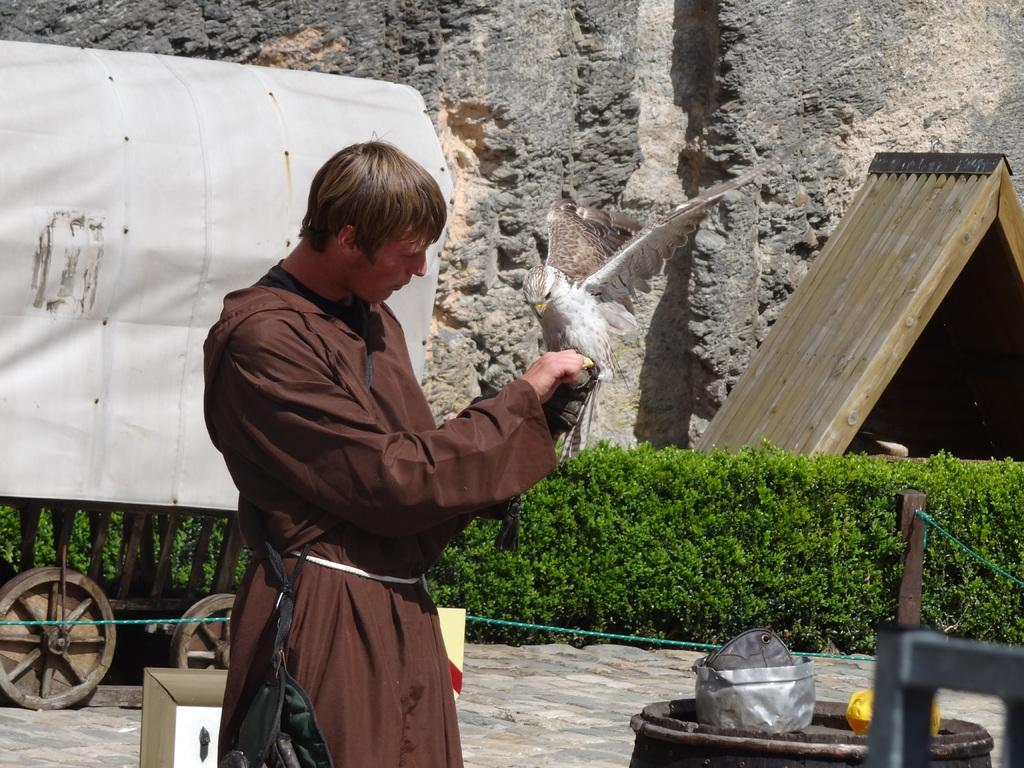What is the main subject of the image? There is a person in the image. What is the person holding in the image? A bird is on the person's hand. What type of vehicle can be seen in the image? There is a kart in the image. What is the purpose of the board in the image? The board's purpose is not clear from the image, but it might be used for support or as a surface for writing or drawing. What type of vegetation is present in the image? There are plants in the image. What is on top of the barrel in the image? There are objects on a barrel in the image. What is the wooden pole used for in the image? The wooden pole's purpose is not clear from the image, but it might be used for support or as a guide. What is the rope used for in the image? The rope's purpose is not clear from the image, but it might be used for tying or hanging objects. What type of structure is visible in the image? There is a wall in the image. What type of shade does the worm provide in the image? There is no worm present in the image, so it cannot provide any shade. 